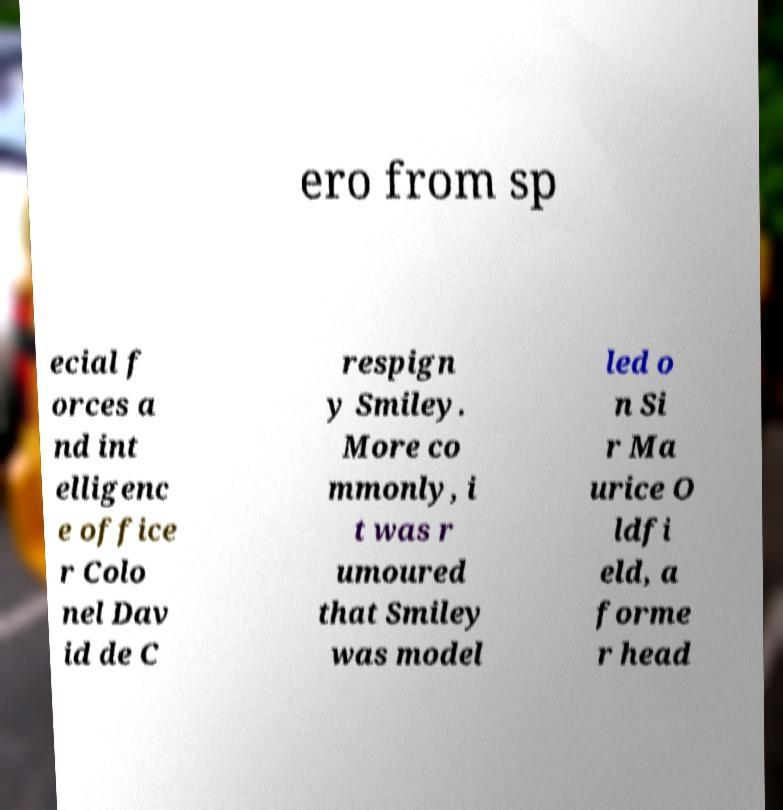Can you accurately transcribe the text from the provided image for me? ero from sp ecial f orces a nd int elligenc e office r Colo nel Dav id de C respign y Smiley. More co mmonly, i t was r umoured that Smiley was model led o n Si r Ma urice O ldfi eld, a forme r head 